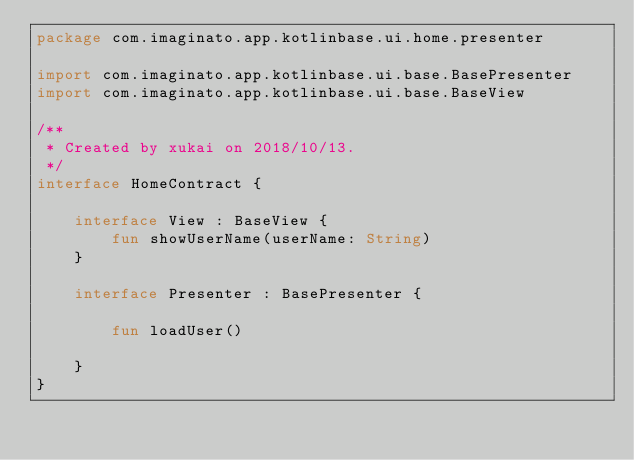<code> <loc_0><loc_0><loc_500><loc_500><_Kotlin_>package com.imaginato.app.kotlinbase.ui.home.presenter

import com.imaginato.app.kotlinbase.ui.base.BasePresenter
import com.imaginato.app.kotlinbase.ui.base.BaseView

/**
 * Created by xukai on 2018/10/13.
 */
interface HomeContract {

    interface View : BaseView {
        fun showUserName(userName: String)
    }

    interface Presenter : BasePresenter {

        fun loadUser()

    }
}</code> 